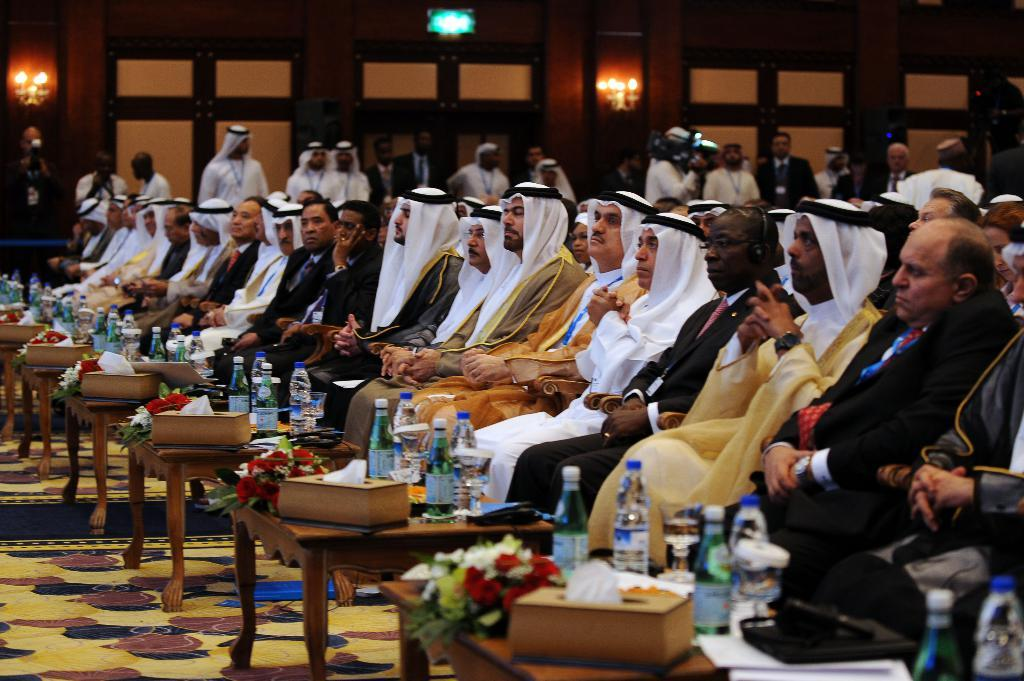How many people are in the image? There is a group of persons in the image. What are the persons doing in the image? The persons are sitting in chairs. What items can be seen in front of the persons? There are water bottles, a flower bouquet, and tissues in front of the persons. What type of church can be seen in the background of the image? There is no church visible in the image. 